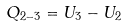<formula> <loc_0><loc_0><loc_500><loc_500>Q _ { 2 - 3 } = U _ { 3 } - U _ { 2 }</formula> 